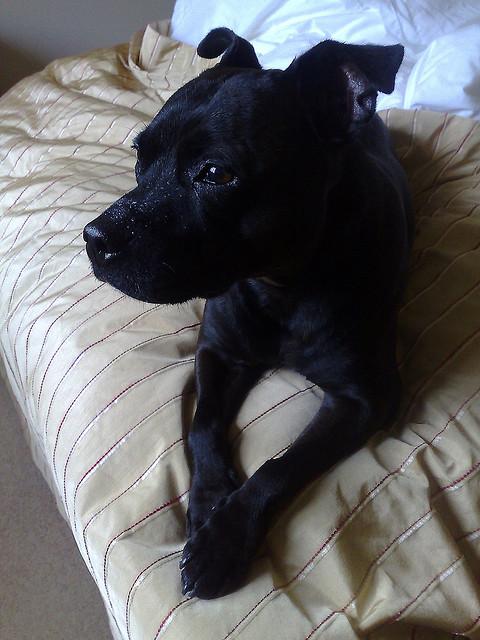Is the dog laying?
Write a very short answer. Yes. What color is the dog?
Give a very brief answer. Black. Is the dog happy?
Concise answer only. Yes. 